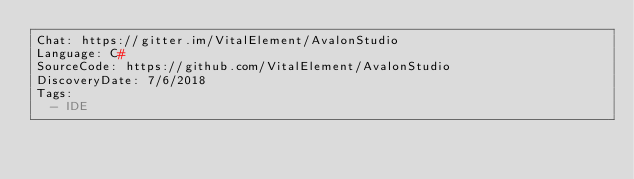Convert code to text. <code><loc_0><loc_0><loc_500><loc_500><_YAML_>Chat: https://gitter.im/VitalElement/AvalonStudio
Language: C#
SourceCode: https://github.com/VitalElement/AvalonStudio
DiscoveryDate: 7/6/2018
Tags:
  - IDE
</code> 